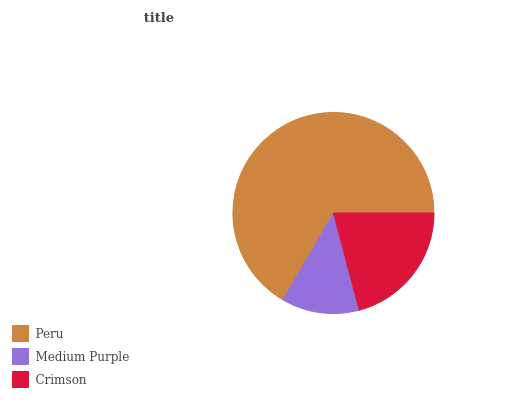Is Medium Purple the minimum?
Answer yes or no. Yes. Is Peru the maximum?
Answer yes or no. Yes. Is Crimson the minimum?
Answer yes or no. No. Is Crimson the maximum?
Answer yes or no. No. Is Crimson greater than Medium Purple?
Answer yes or no. Yes. Is Medium Purple less than Crimson?
Answer yes or no. Yes. Is Medium Purple greater than Crimson?
Answer yes or no. No. Is Crimson less than Medium Purple?
Answer yes or no. No. Is Crimson the high median?
Answer yes or no. Yes. Is Crimson the low median?
Answer yes or no. Yes. Is Peru the high median?
Answer yes or no. No. Is Medium Purple the low median?
Answer yes or no. No. 